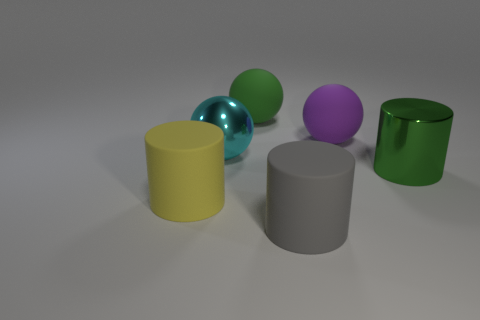Add 4 gray matte cylinders. How many objects exist? 10 Subtract 0 brown cylinders. How many objects are left? 6 Subtract all large purple rubber things. Subtract all big metallic balls. How many objects are left? 4 Add 2 big purple matte balls. How many big purple matte balls are left? 3 Add 6 big cyan cubes. How many big cyan cubes exist? 6 